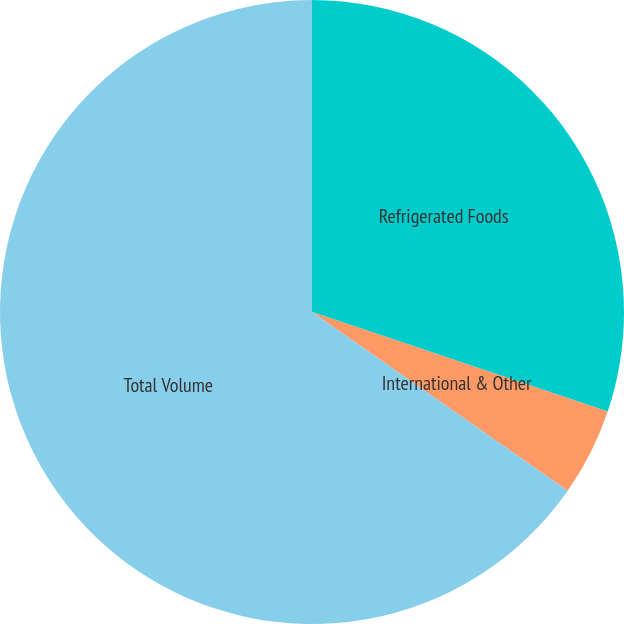<chart> <loc_0><loc_0><loc_500><loc_500><pie_chart><fcel>Refrigerated Foods<fcel>International & Other<fcel>Total Volume<nl><fcel>30.17%<fcel>4.54%<fcel>65.29%<nl></chart> 